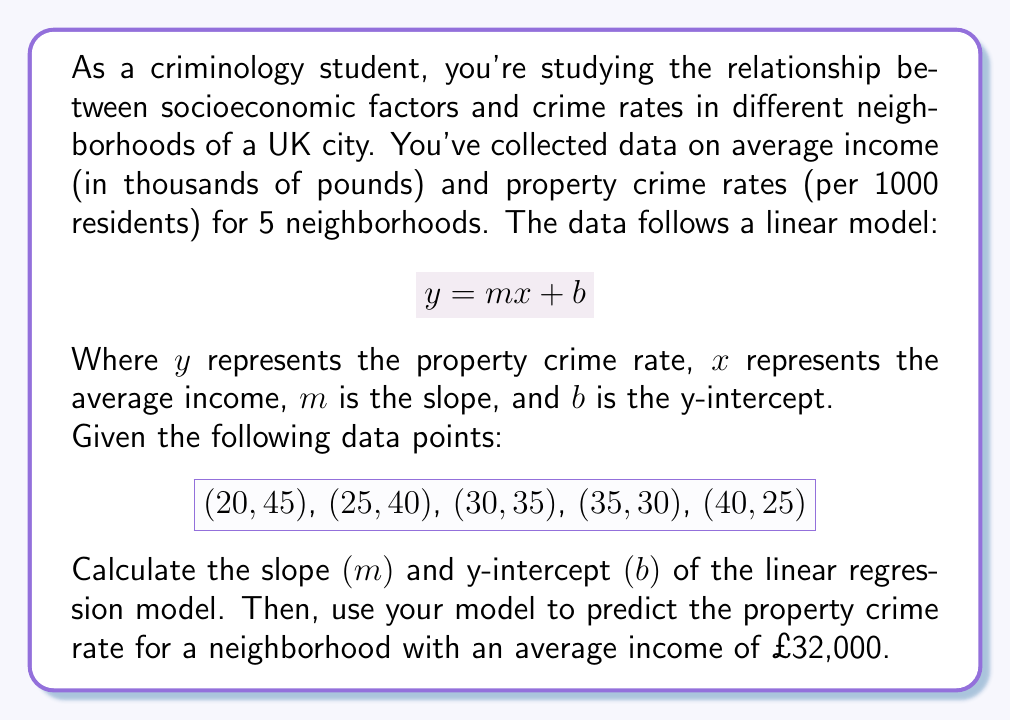Teach me how to tackle this problem. To solve this problem, we'll follow these steps:

1. Calculate the slope $(m)$ using the formula:
   $$m = \frac{\sum_{i=1}^{n} (x_i - \bar{x})(y_i - \bar{y})}{\sum_{i=1}^{n} (x_i - \bar{x})^2}$$

2. Calculate the y-intercept $(b)$ using the formula:
   $$b = \bar{y} - m\bar{x}$$

3. Use the linear equation to predict the crime rate for the given income.

Step 1: Calculate the slope $(m)$

First, we need to calculate $\bar{x}$ and $\bar{y}$:
$$\bar{x} = \frac{20 + 25 + 30 + 35 + 40}{5} = 30$$
$$\bar{y} = \frac{45 + 40 + 35 + 30 + 25}{5} = 35$$

Now, let's calculate the numerator and denominator of the slope formula:

Numerator: $\sum_{i=1}^{n} (x_i - \bar{x})(y_i - \bar{y})$
$$(20-30)(45-35) + (25-30)(40-35) + (30-30)(35-35) + (35-30)(30-35) + (40-30)(25-35)$$
$$= (-10)(10) + (-5)(5) + (0)(0) + (5)(-5) + (10)(-10)$$
$$= -100 - 25 + 0 - 25 - 100 = -250$$

Denominator: $\sum_{i=1}^{n} (x_i - \bar{x})^2$
$$(20-30)^2 + (25-30)^2 + (30-30)^2 + (35-30)^2 + (40-30)^2$$
$$= (-10)^2 + (-5)^2 + (0)^2 + (5)^2 + (10)^2$$
$$= 100 + 25 + 0 + 25 + 100 = 250$$

Therefore, the slope is:
$$m = \frac{-250}{250} = -1$$

Step 2: Calculate the y-intercept $(b)$

Using the formula $b = \bar{y} - m\bar{x}$:
$$b = 35 - (-1)(30) = 35 + 30 = 65$$

Our linear regression model is:
$$y = -x + 65$$

Step 3: Predict the crime rate for an average income of £32,000

To predict the crime rate, we substitute $x = 32$ into our equation:
$$y = -32 + 65 = 33$$

Therefore, the predicted property crime rate for a neighborhood with an average income of £32,000 is 33 per 1000 residents.
Answer: The linear regression model is $y = -x + 65$, where $x$ is the average income in thousands of pounds and $y$ is the property crime rate per 1000 residents. For a neighborhood with an average income of £32,000, the predicted property crime rate is 33 per 1000 residents. 